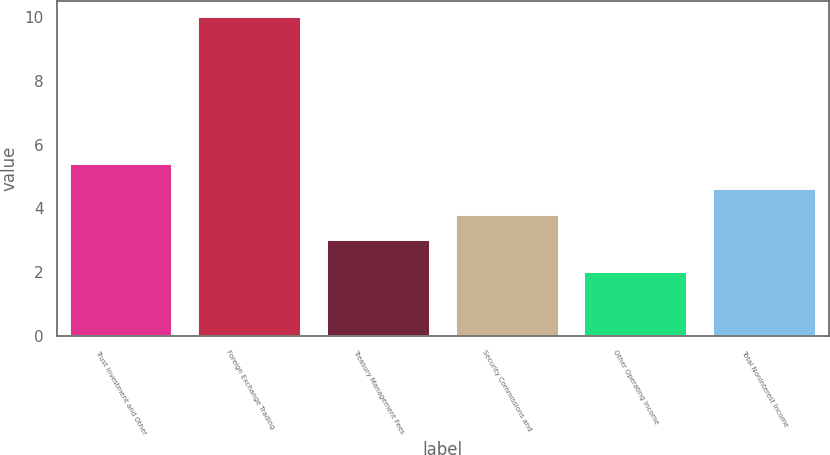Convert chart to OTSL. <chart><loc_0><loc_0><loc_500><loc_500><bar_chart><fcel>Trust Investment and Other<fcel>Foreign Exchange Trading<fcel>Treasury Management Fees<fcel>Security Commissions and<fcel>Other Operating Income<fcel>Total Noninterest Income<nl><fcel>5.4<fcel>10<fcel>3<fcel>3.8<fcel>2<fcel>4.6<nl></chart> 